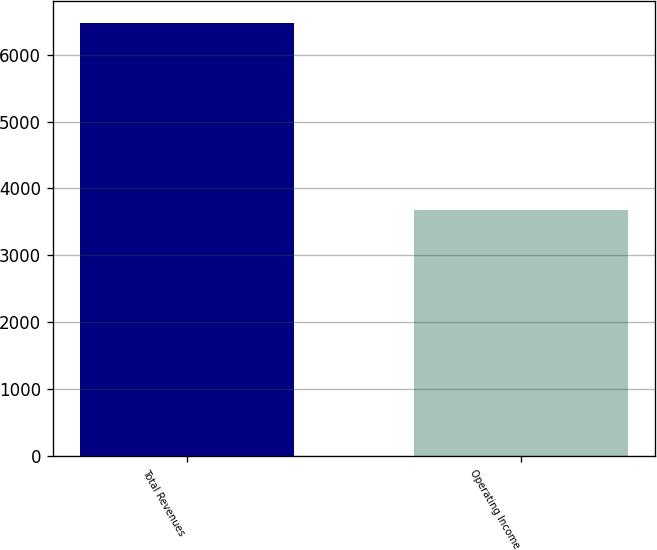Convert chart. <chart><loc_0><loc_0><loc_500><loc_500><bar_chart><fcel>Total Revenues<fcel>Operating Income<nl><fcel>6474<fcel>3675<nl></chart> 